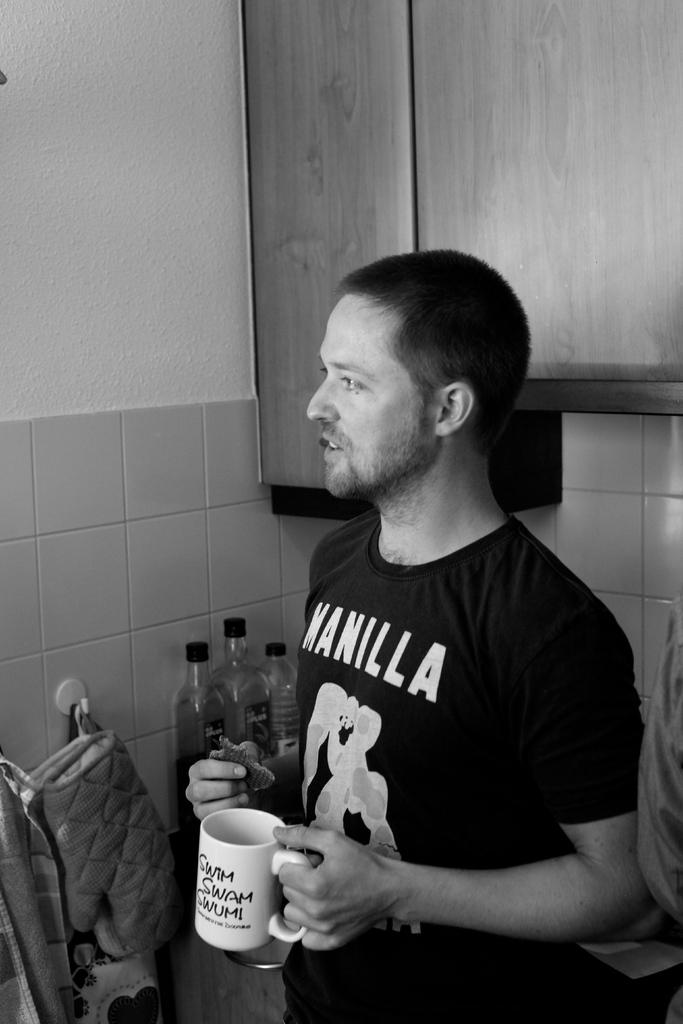What is the main subject of the image? There is a man standing in the image. What is the man holding in his hand? The man is holding a mug in one hand. Are there any other objects visible in the image? Yes, there are a few bottles and a biscuit in the image. What type of sea creature can be seen swimming near the man in the image? There is no sea creature present in the image; it features a man standing with a mug and other objects. How many eyes does the donkey have in the image? There is no donkey present in the image. 